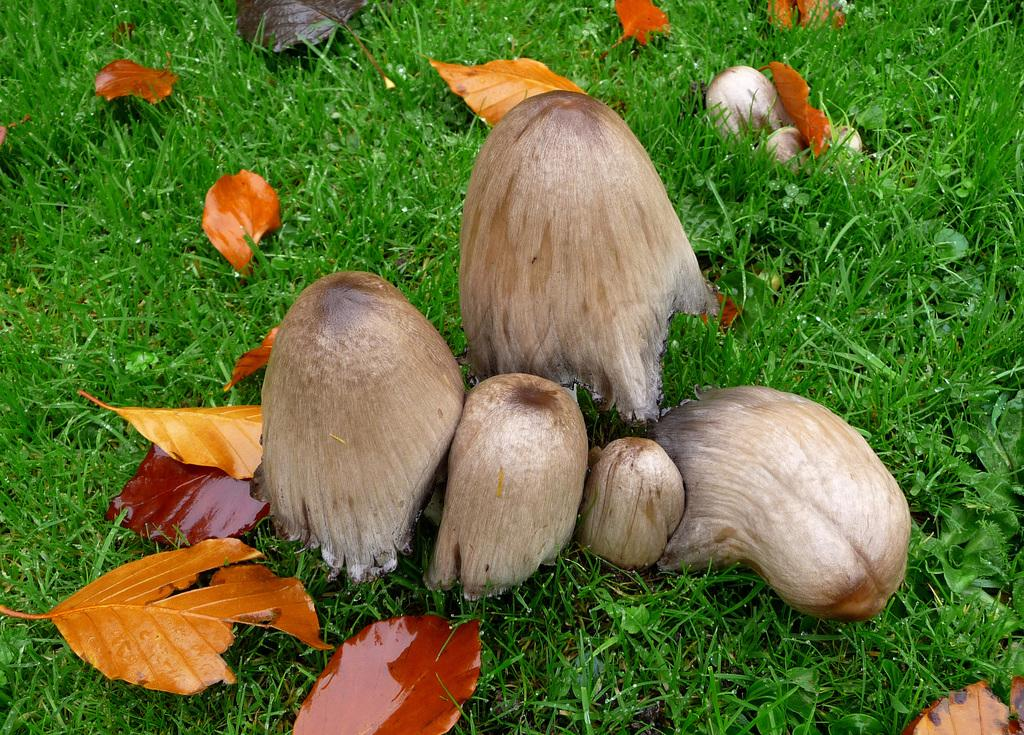What type of vegetation can be seen on the ground in the image? There are mushrooms, dried leaves, and grass on the ground in the image. Can you describe the ground in the image? The ground is covered with mushrooms, dried leaves, and grass. What type of pot is visible in the image? There is no pot present in the image; it only features mushrooms, dried leaves, and grass on the ground. Can you describe the goose that is sitting on the grass in the image? There is no goose present in the image; it only features mushrooms, dried leaves, and grass on the ground. 